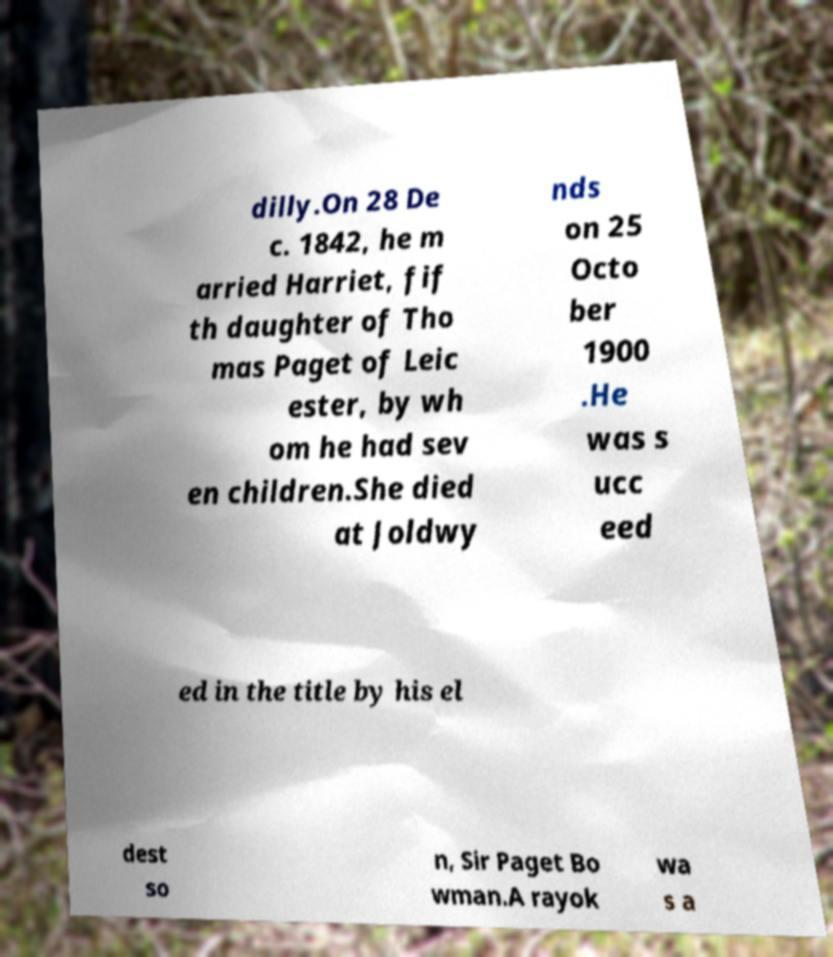Could you assist in decoding the text presented in this image and type it out clearly? dilly.On 28 De c. 1842, he m arried Harriet, fif th daughter of Tho mas Paget of Leic ester, by wh om he had sev en children.She died at Joldwy nds on 25 Octo ber 1900 .He was s ucc eed ed in the title by his el dest so n, Sir Paget Bo wman.A rayok wa s a 